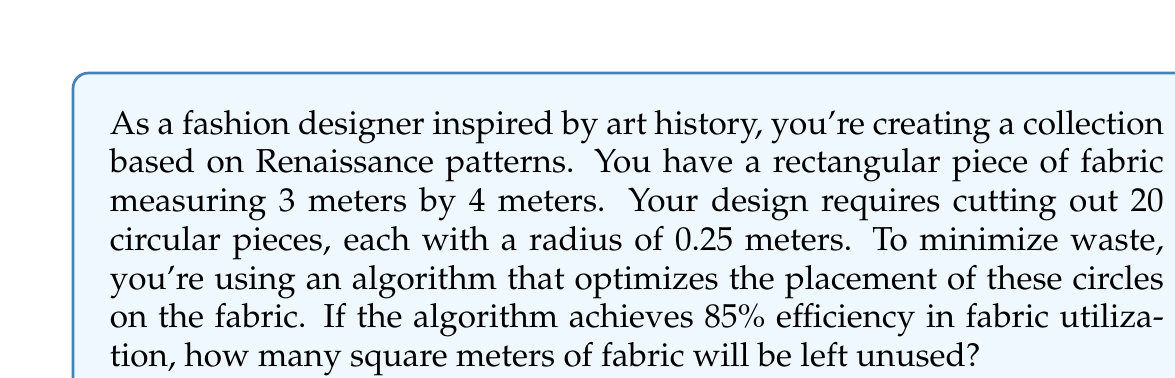Can you solve this math problem? Let's approach this step-by-step:

1. Calculate the total area of the fabric:
   $$A_{total} = 3m \times 4m = 12m^2$$

2. Calculate the area of each circular piece:
   $$A_{circle} = \pi r^2 = \pi (0.25m)^2 = 0.1963m^2$$

3. Calculate the total area of all 20 circular pieces:
   $$A_{all\_circles} = 20 \times 0.1963m^2 = 3.9270m^2$$

4. The algorithm's efficiency is 85%, which means 85% of the fabric is utilized. To find the used area:
   $$A_{used} = 85\% \times 12m^2 = 0.85 \times 12m^2 = 10.2m^2$$

5. The unused area is the difference between the total area and the used area:
   $$A_{unused} = A_{total} - A_{used} = 12m^2 - 10.2m^2 = 1.8m^2$$

This result makes sense because:
- The total area of circles (3.9270m²) is less than the used area (10.2m²), accounting for inevitable waste between circles.
- The unused area (1.8m²) is positive and less than the total area, as expected.
Answer: 1.8 square meters 